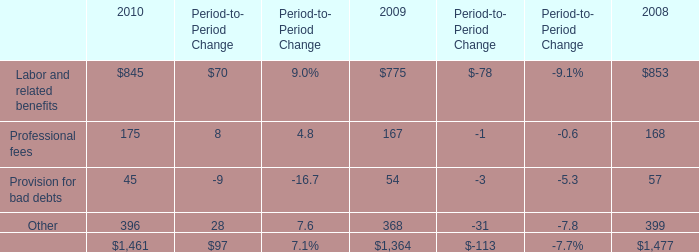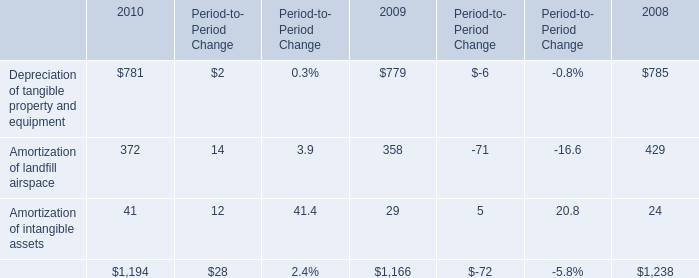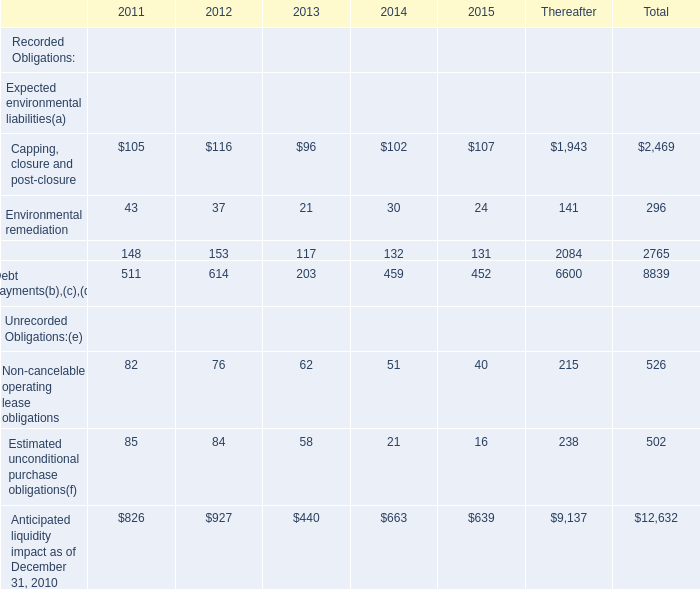What is the ratio of Amortization of landfill airspace in Table 1 to the Professional fees in Table 0 in 2009? 
Computations: (358 / 167)
Answer: 2.14371. 